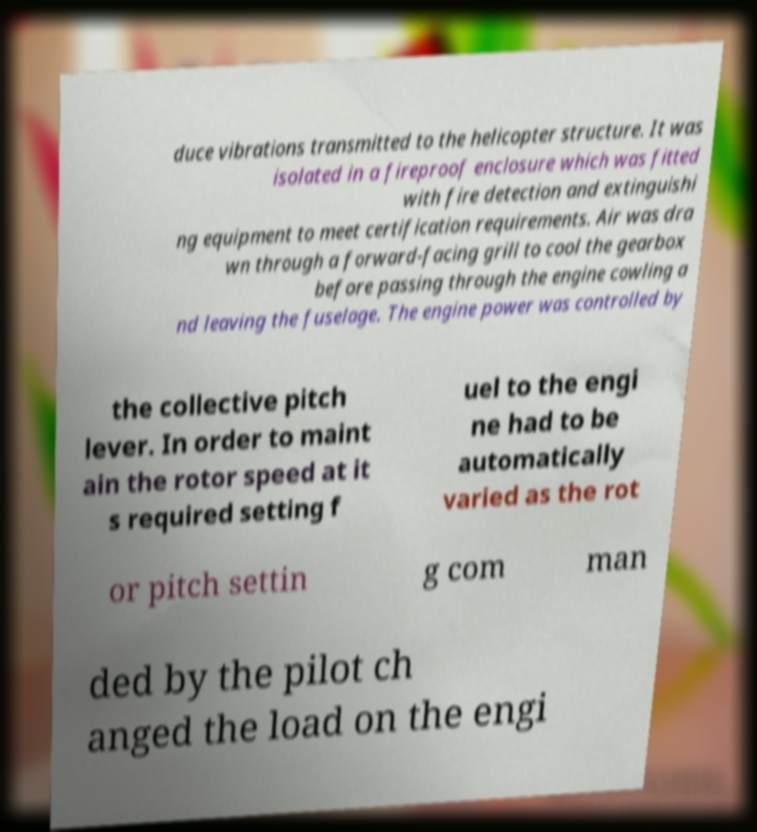Can you read and provide the text displayed in the image?This photo seems to have some interesting text. Can you extract and type it out for me? duce vibrations transmitted to the helicopter structure. It was isolated in a fireproof enclosure which was fitted with fire detection and extinguishi ng equipment to meet certification requirements. Air was dra wn through a forward-facing grill to cool the gearbox before passing through the engine cowling a nd leaving the fuselage. The engine power was controlled by the collective pitch lever. In order to maint ain the rotor speed at it s required setting f uel to the engi ne had to be automatically varied as the rot or pitch settin g com man ded by the pilot ch anged the load on the engi 